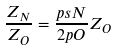<formula> <loc_0><loc_0><loc_500><loc_500>\frac { Z _ { N } } { Z _ { O } } = \frac { p s N } { 2 p O } Z _ { O }</formula> 